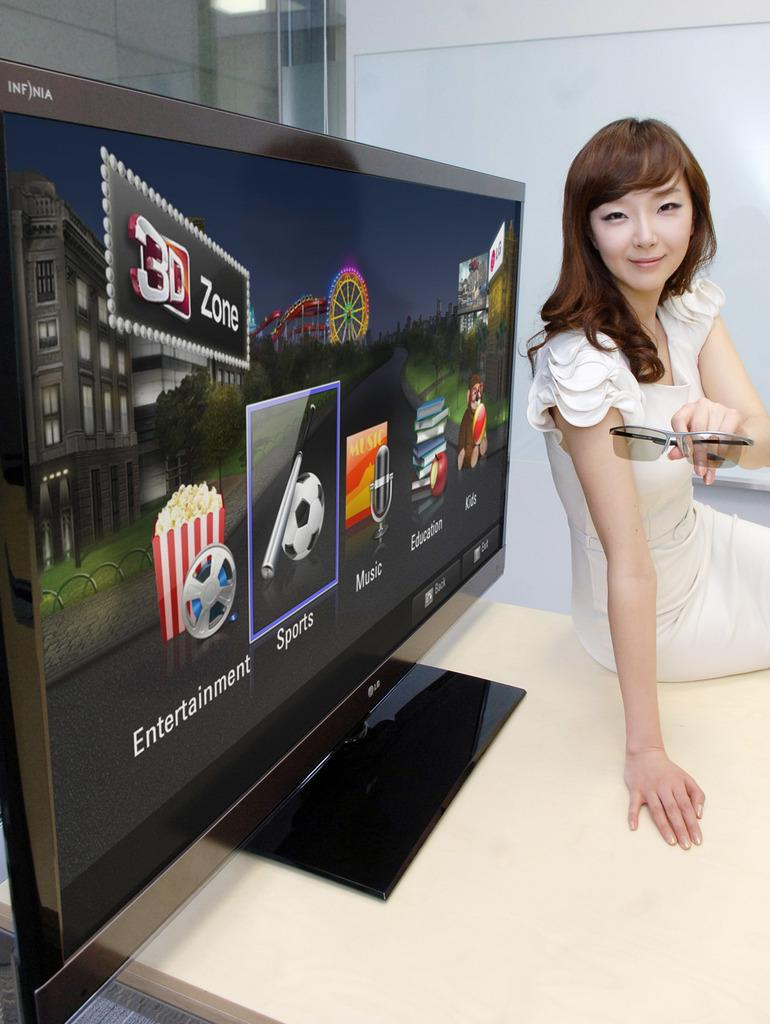<image>
Provide a brief description of the given image. A young woman in front of a TV that is advertising entertainment, sports, and music in the 3 D zone. 